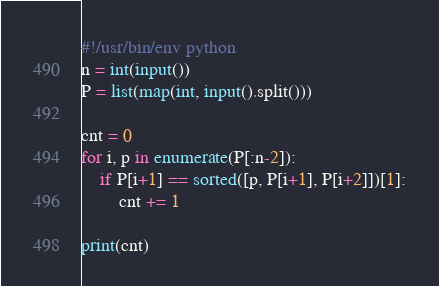<code> <loc_0><loc_0><loc_500><loc_500><_Python_>#!/usr/bin/env python
n = int(input())
P = list(map(int, input().split()))

cnt = 0
for i, p in enumerate(P[:n-2]):
    if P[i+1] == sorted([p, P[i+1], P[i+2]])[1]:
        cnt += 1

print(cnt)
</code> 